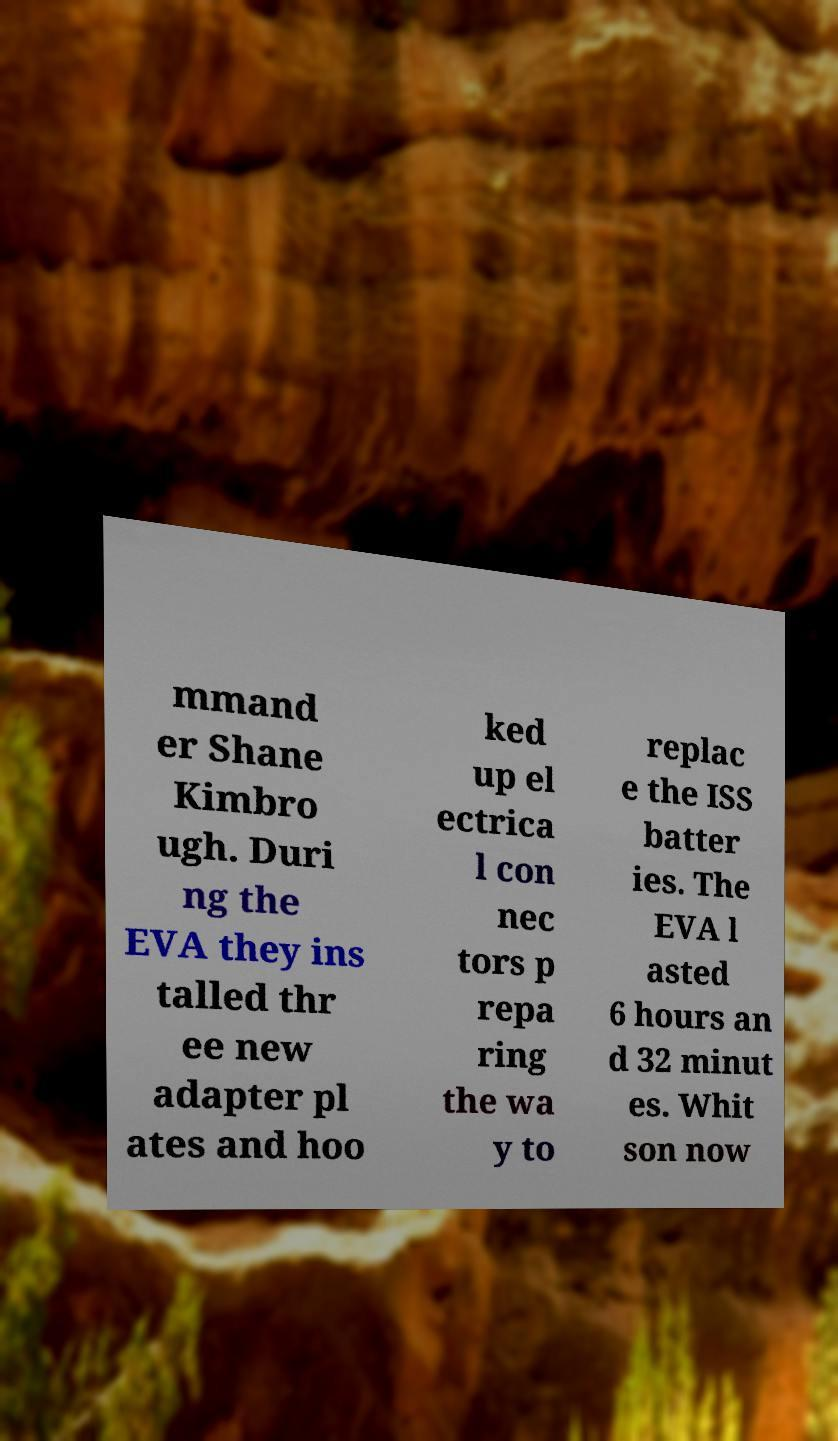Could you assist in decoding the text presented in this image and type it out clearly? mmand er Shane Kimbro ugh. Duri ng the EVA they ins talled thr ee new adapter pl ates and hoo ked up el ectrica l con nec tors p repa ring the wa y to replac e the ISS batter ies. The EVA l asted 6 hours an d 32 minut es. Whit son now 